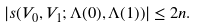Convert formula to latex. <formula><loc_0><loc_0><loc_500><loc_500>| s ( V _ { 0 } , V _ { 1 } ; \Lambda ( 0 ) , \Lambda ( 1 ) ) | \leq 2 n .</formula> 